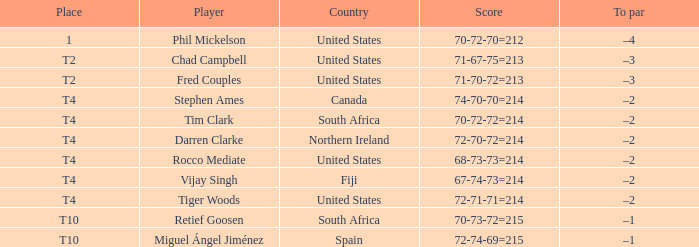What par does rocco mediate have? –2. 